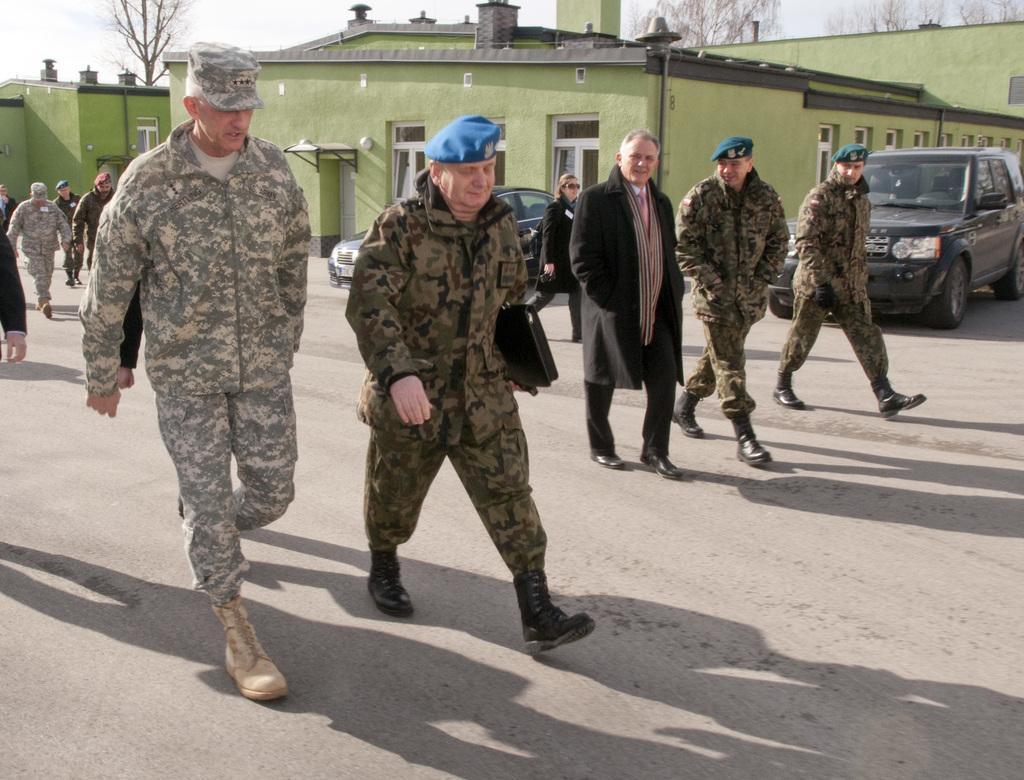Can you describe this image briefly? In this picture we can see five military men wearing green dress walking on the road. Behind there is a green color house and black color range rover car is parked. 